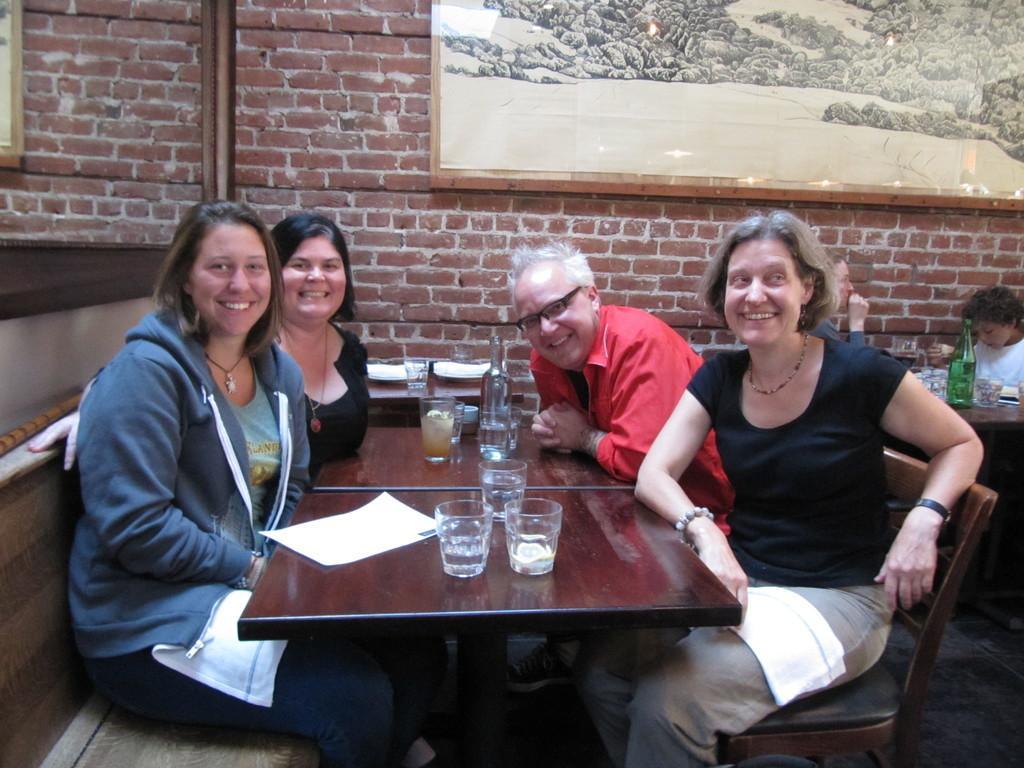Could you give a brief overview of what you see in this image? In this picture we can see three woman and one man sitting on chair and smiling and in front of them we can see table and on table we have glasses, bottle, paper and in background we can see wall, frames, pipes and some other persons. 